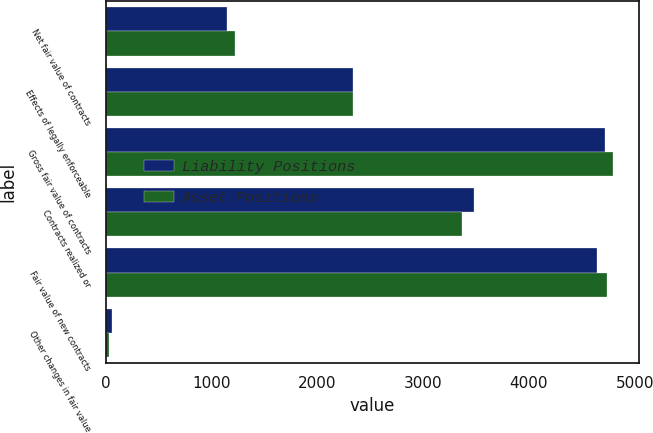Convert chart to OTSL. <chart><loc_0><loc_0><loc_500><loc_500><stacked_bar_chart><ecel><fcel>Net fair value of contracts<fcel>Effects of legally enforceable<fcel>Gross fair value of contracts<fcel>Contracts realized or<fcel>Fair value of new contracts<fcel>Other changes in fair value<nl><fcel>Liability Positions<fcel>1148<fcel>2339<fcel>4721<fcel>3477<fcel>4646<fcel>59<nl><fcel>Asset Positions<fcel>1226<fcel>2339<fcel>4799<fcel>3372<fcel>4736<fcel>34<nl></chart> 